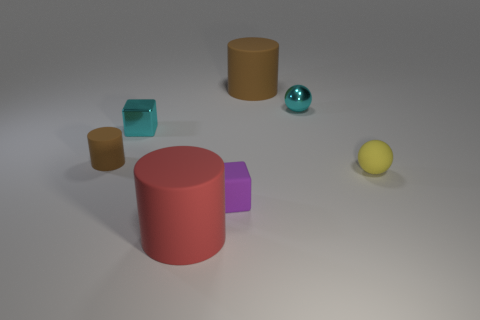What could be the purpose of creating an image like this? An image like this might be used for various purposes. It could serve as a visual aid in tutorials about 3D rendering techniques, an example for lessons on color theory and shading, or as a component in a psychological test to ascertain cognitive functions related to perception and spatial reasoning. Could the image be of any interest to designers or artists? Absolutely, designers and artists might find inspiration in such an image for understanding how different shapes and colors interact within a space. It might also interest them as a reference for experimenting with composition or lighting in their own work. 